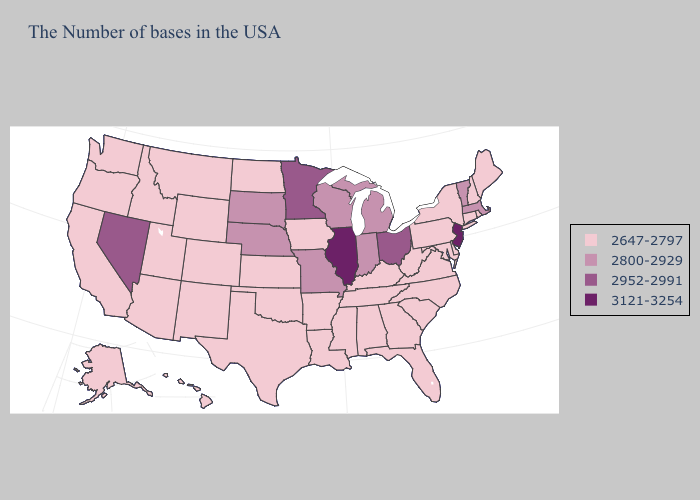Name the states that have a value in the range 3121-3254?
Concise answer only. New Jersey, Illinois. Name the states that have a value in the range 2800-2929?
Be succinct. Massachusetts, Vermont, Michigan, Indiana, Wisconsin, Missouri, Nebraska, South Dakota. Among the states that border Utah , which have the lowest value?
Give a very brief answer. Wyoming, Colorado, New Mexico, Arizona, Idaho. Name the states that have a value in the range 3121-3254?
Quick response, please. New Jersey, Illinois. What is the highest value in the South ?
Give a very brief answer. 2647-2797. What is the value of Delaware?
Short answer required. 2647-2797. Does the map have missing data?
Concise answer only. No. Name the states that have a value in the range 2952-2991?
Answer briefly. Ohio, Minnesota, Nevada. What is the value of Massachusetts?
Be succinct. 2800-2929. Is the legend a continuous bar?
Concise answer only. No. What is the value of Mississippi?
Short answer required. 2647-2797. Name the states that have a value in the range 3121-3254?
Short answer required. New Jersey, Illinois. What is the value of Mississippi?
Keep it brief. 2647-2797. What is the value of Wyoming?
Quick response, please. 2647-2797. Name the states that have a value in the range 2952-2991?
Quick response, please. Ohio, Minnesota, Nevada. 